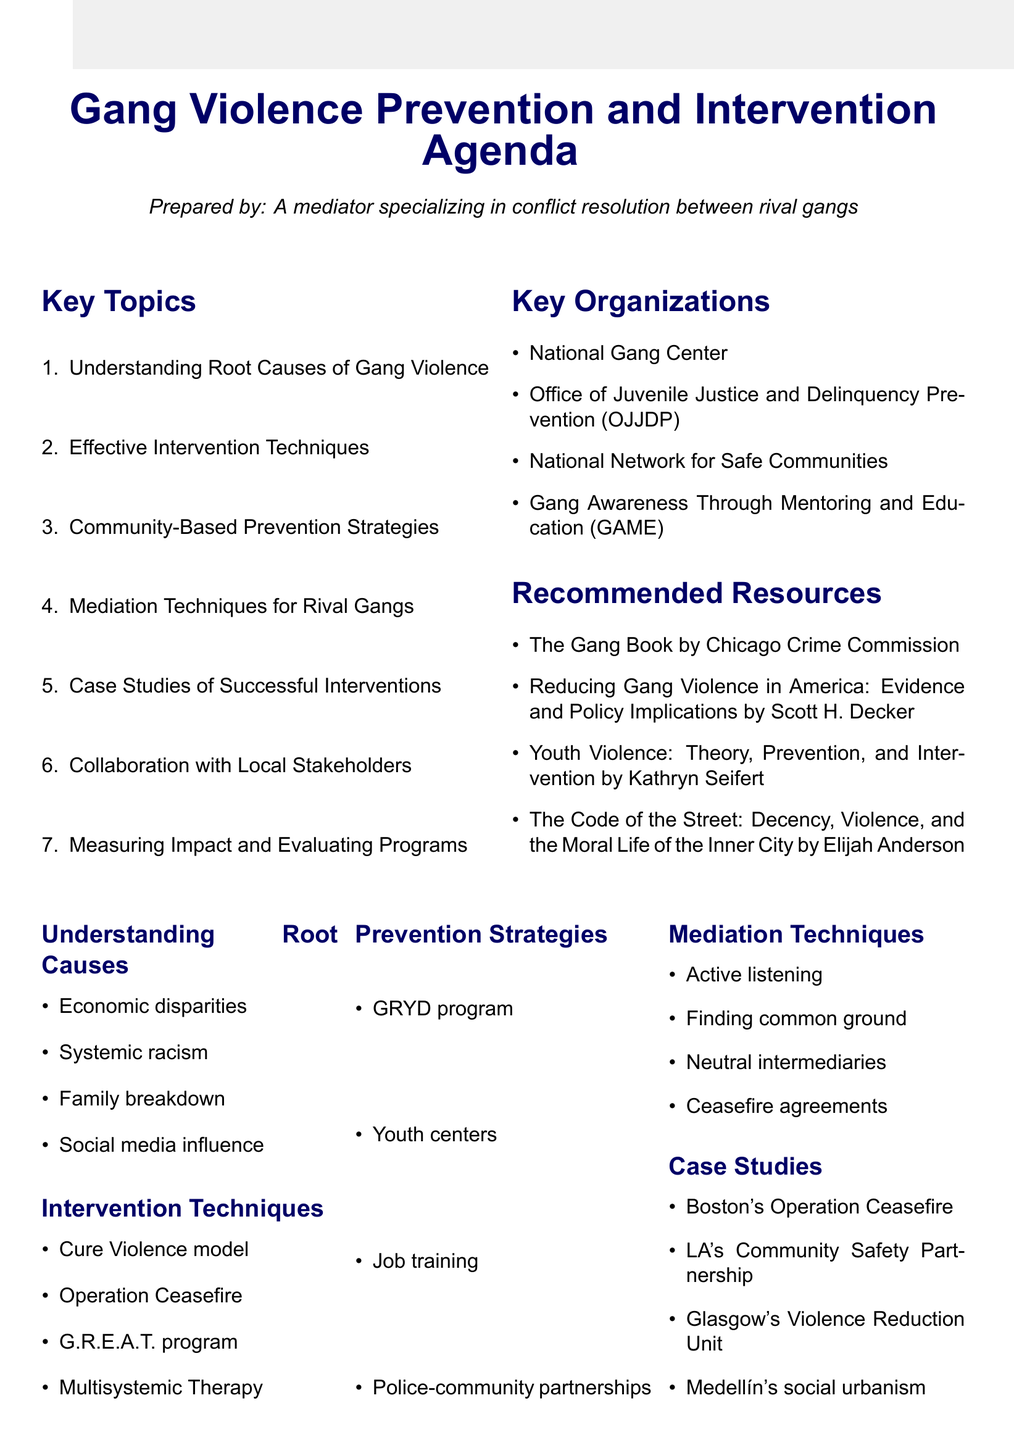What is the first topic listed in the agenda? The first topic listed is "Understanding Root Causes of Gang Violence."
Answer: Understanding Root Causes of Gang Violence What model treats violence as a public health issue? The Cure Violence model is mentioned as treating violence as a public health issue.
Answer: Cure Violence model Which city's program is related to youth development? The Los Angeles Gang Reduction and Youth Development (GRYD) program is mentioned.
Answer: Los Angeles Gang Reduction and Youth Development (GRYD) program What is one technique for mediation mentioned in the agenda? "Active listening" is included as a mediation technique.
Answer: Active listening How many case studies of successful interventions are listed? There are four case studies of successful interventions listed in the agenda.
Answer: Four What type of organizations do we engage to help reduce gang violence? Faith-based organizations like the Nation of Islam and Catholic Charities are listed as key collaborators.
Answer: Faith-based organizations What does the CompStat model help with? The CompStat model helps in data-driven decision making as stated in the document.
Answer: Data-driven decision making Which program is related to high-risk youth and therapy? Multisystemic Therapy (MST) is the program mentioned for high-risk youth.
Answer: Multisystemic Therapy (MST) What type of strategy is the Chicago Alternative Policing Strategy (CAPS)? CAPS is mentioned as an initiative for fostering police-community partnerships.
Answer: Initiative for fostering police-community partnerships 